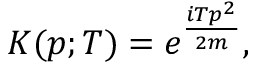<formula> <loc_0><loc_0><loc_500><loc_500>K ( p ; T ) = e ^ { \frac { i T p ^ { 2 } } { 2 m } } ,</formula> 